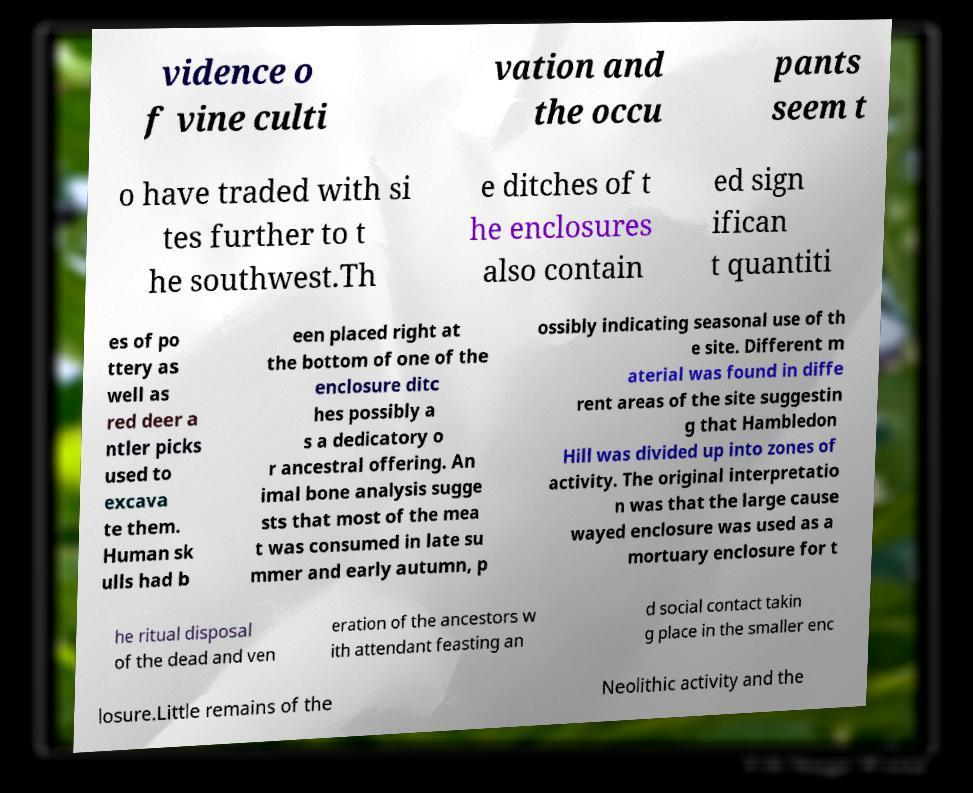Can you read and provide the text displayed in the image?This photo seems to have some interesting text. Can you extract and type it out for me? vidence o f vine culti vation and the occu pants seem t o have traded with si tes further to t he southwest.Th e ditches of t he enclosures also contain ed sign ifican t quantiti es of po ttery as well as red deer a ntler picks used to excava te them. Human sk ulls had b een placed right at the bottom of one of the enclosure ditc hes possibly a s a dedicatory o r ancestral offering. An imal bone analysis sugge sts that most of the mea t was consumed in late su mmer and early autumn, p ossibly indicating seasonal use of th e site. Different m aterial was found in diffe rent areas of the site suggestin g that Hambledon Hill was divided up into zones of activity. The original interpretatio n was that the large cause wayed enclosure was used as a mortuary enclosure for t he ritual disposal of the dead and ven eration of the ancestors w ith attendant feasting an d social contact takin g place in the smaller enc losure.Little remains of the Neolithic activity and the 